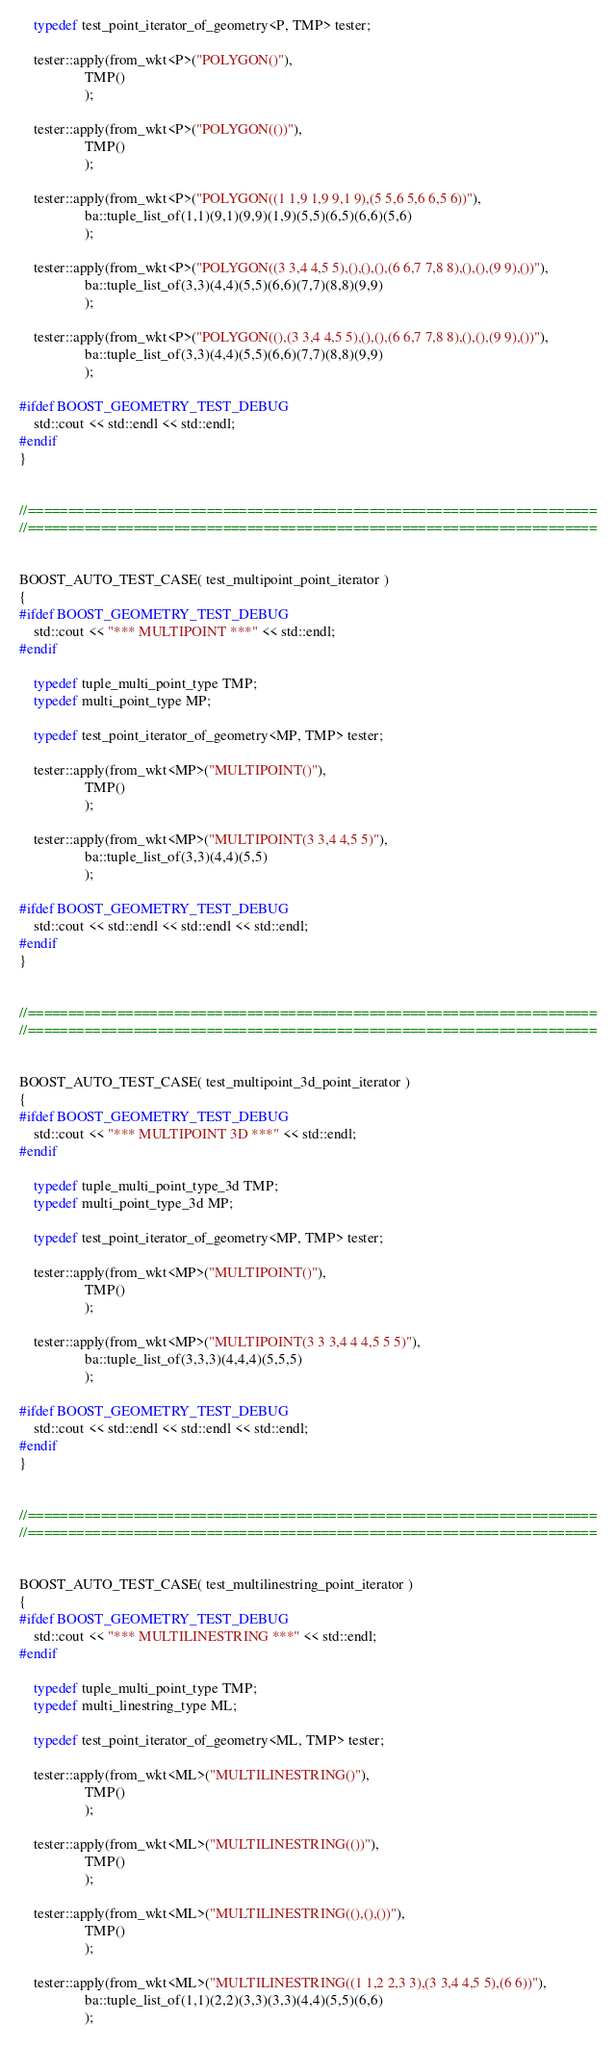<code> <loc_0><loc_0><loc_500><loc_500><_C++_>
    typedef test_point_iterator_of_geometry<P, TMP> tester;

    tester::apply(from_wkt<P>("POLYGON()"),
                  TMP()
                  );

    tester::apply(from_wkt<P>("POLYGON(())"),
                  TMP()
                  );

    tester::apply(from_wkt<P>("POLYGON((1 1,9 1,9 9,1 9),(5 5,6 5,6 6,5 6))"),
                  ba::tuple_list_of(1,1)(9,1)(9,9)(1,9)(5,5)(6,5)(6,6)(5,6)
                  );

    tester::apply(from_wkt<P>("POLYGON((3 3,4 4,5 5),(),(),(),(6 6,7 7,8 8),(),(),(9 9),())"),
                  ba::tuple_list_of(3,3)(4,4)(5,5)(6,6)(7,7)(8,8)(9,9)
                  );

    tester::apply(from_wkt<P>("POLYGON((),(3 3,4 4,5 5),(),(),(6 6,7 7,8 8),(),(),(9 9),())"),
                  ba::tuple_list_of(3,3)(4,4)(5,5)(6,6)(7,7)(8,8)(9,9)
                  );

#ifdef BOOST_GEOMETRY_TEST_DEBUG
    std::cout << std::endl << std::endl;
#endif
}


//======================================================================
//======================================================================


BOOST_AUTO_TEST_CASE( test_multipoint_point_iterator )
{
#ifdef BOOST_GEOMETRY_TEST_DEBUG
    std::cout << "*** MULTIPOINT ***" << std::endl;
#endif

    typedef tuple_multi_point_type TMP;
    typedef multi_point_type MP;

    typedef test_point_iterator_of_geometry<MP, TMP> tester;

    tester::apply(from_wkt<MP>("MULTIPOINT()"),
                  TMP()
                  );

    tester::apply(from_wkt<MP>("MULTIPOINT(3 3,4 4,5 5)"),
                  ba::tuple_list_of(3,3)(4,4)(5,5)
                  );

#ifdef BOOST_GEOMETRY_TEST_DEBUG
    std::cout << std::endl << std::endl << std::endl;
#endif
}


//======================================================================
//======================================================================


BOOST_AUTO_TEST_CASE( test_multipoint_3d_point_iterator )
{
#ifdef BOOST_GEOMETRY_TEST_DEBUG
    std::cout << "*** MULTIPOINT 3D ***" << std::endl;
#endif

    typedef tuple_multi_point_type_3d TMP;
    typedef multi_point_type_3d MP;

    typedef test_point_iterator_of_geometry<MP, TMP> tester;

    tester::apply(from_wkt<MP>("MULTIPOINT()"),
                  TMP()
                  );

    tester::apply(from_wkt<MP>("MULTIPOINT(3 3 3,4 4 4,5 5 5)"),
                  ba::tuple_list_of(3,3,3)(4,4,4)(5,5,5)
                  );

#ifdef BOOST_GEOMETRY_TEST_DEBUG
    std::cout << std::endl << std::endl << std::endl;
#endif
}


//======================================================================
//======================================================================


BOOST_AUTO_TEST_CASE( test_multilinestring_point_iterator )
{
#ifdef BOOST_GEOMETRY_TEST_DEBUG
    std::cout << "*** MULTILINESTRING ***" << std::endl;
#endif

    typedef tuple_multi_point_type TMP;
    typedef multi_linestring_type ML;

    typedef test_point_iterator_of_geometry<ML, TMP> tester;

    tester::apply(from_wkt<ML>("MULTILINESTRING()"),
                  TMP()
                  );

    tester::apply(from_wkt<ML>("MULTILINESTRING(())"),
                  TMP()
                  );

    tester::apply(from_wkt<ML>("MULTILINESTRING((),(),())"),
                  TMP()
                  );

    tester::apply(from_wkt<ML>("MULTILINESTRING((1 1,2 2,3 3),(3 3,4 4,5 5),(6 6))"),
                  ba::tuple_list_of(1,1)(2,2)(3,3)(3,3)(4,4)(5,5)(6,6)
                  );
</code> 